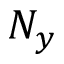Convert formula to latex. <formula><loc_0><loc_0><loc_500><loc_500>N _ { y }</formula> 